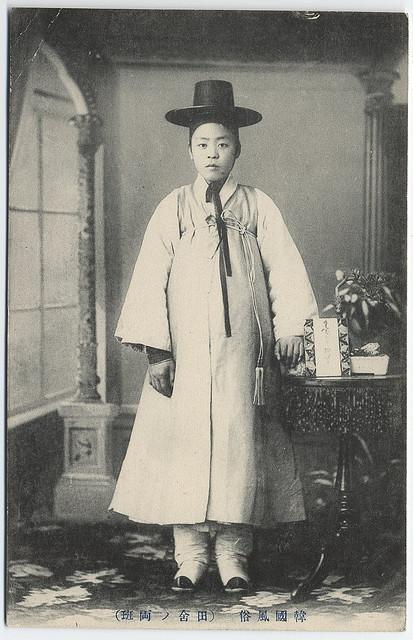How many people are here?
Give a very brief answer. 1. 